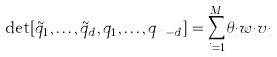Convert formula to latex. <formula><loc_0><loc_0><loc_500><loc_500>\det [ \tilde { q } _ { 1 } , \dots , \tilde { q } _ { d } , q _ { 1 } , \dots , q _ { m - d } ] = \sum _ { i = 1 } ^ { M } \theta _ { i } w _ { i } v _ { i }</formula> 